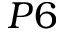Convert formula to latex. <formula><loc_0><loc_0><loc_500><loc_500>P 6</formula> 